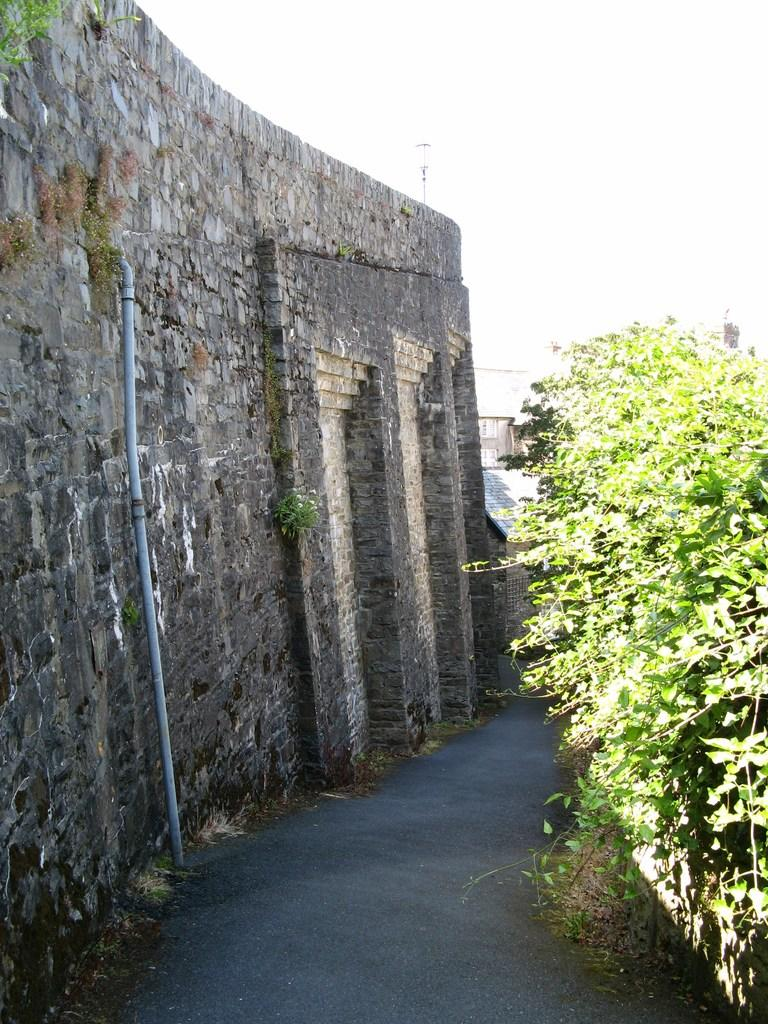What is the main feature of the image? There is a road in the image. What can be seen to the left of the road? There is a wall to the left of the road. What is located near the wall? There is a pipe near the wall. What is present to the right of the road? There are many plants to the right of the road. What is the color of the sky in the background of the image? The sky is white in the background of the image. What type of appliance can be seen flying in the sky in the image? There is no appliance flying in the sky in the image; the sky is white in the background. What material is the pipe made of in the image? The facts provided do not specify the material of the pipe, so we cannot determine its composition from the image. 